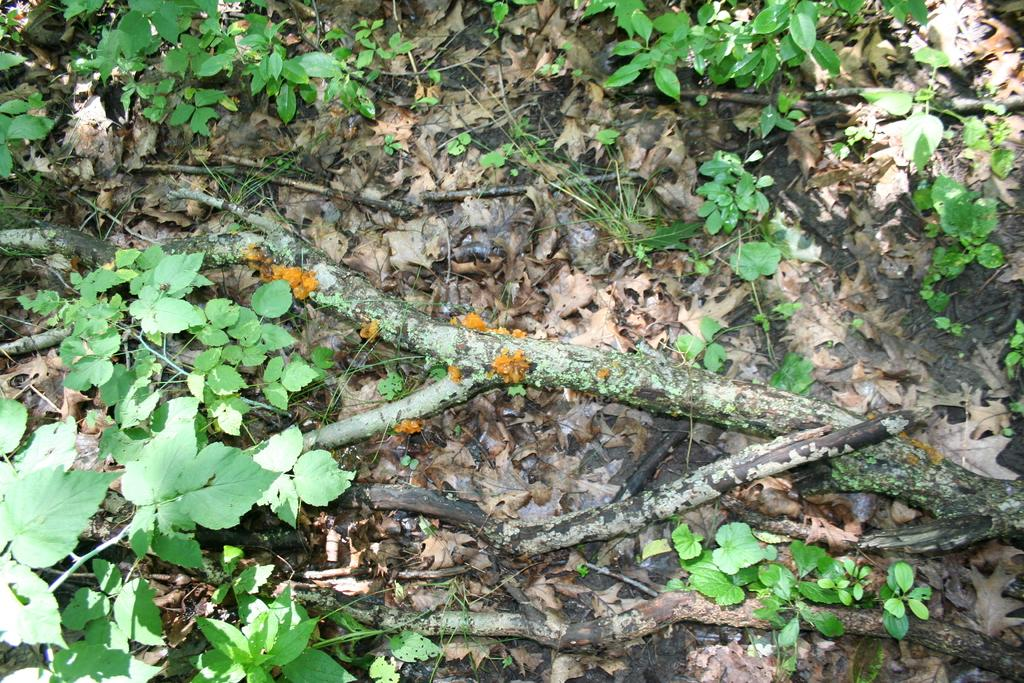What type of vegetation can be seen in the image? There are plants in the image. What other objects are visible in the image? There are sticks in the image. What can be found on the ground in the image? Dry leaves are present on the ground in the image. What type of snow can be seen on the ground in the image? There is no snow present in the image; it features plants, sticks, and dry leaves on the ground. 